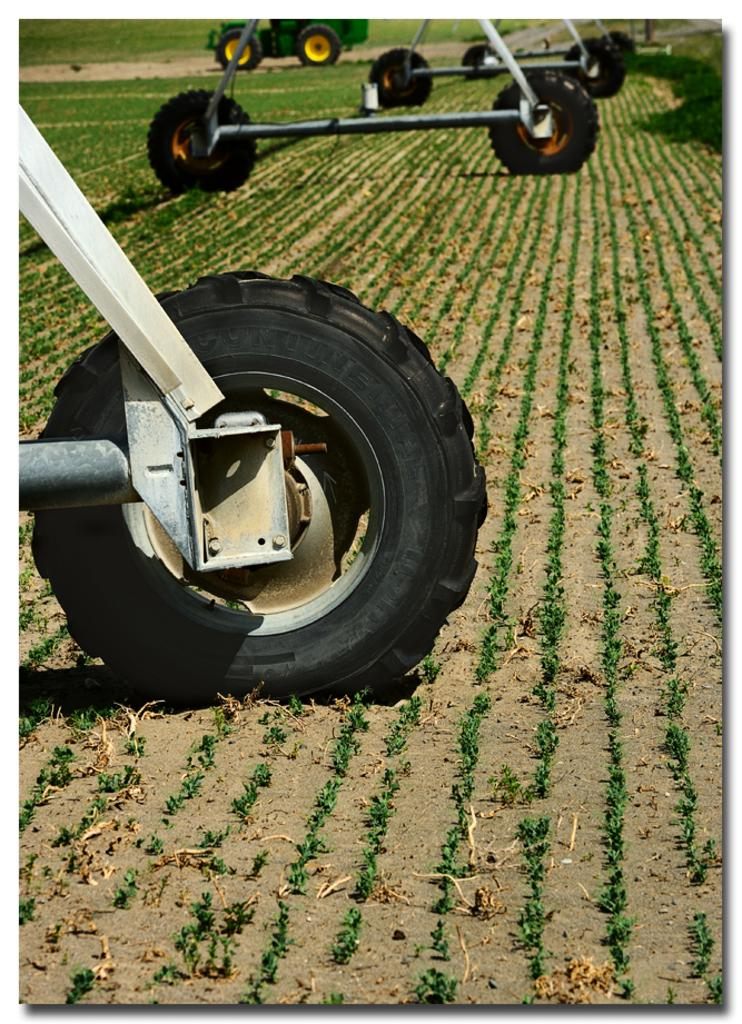What type of objects with wheels can be seen in the image? There are vehicles with wheels in the image. What type of landscape is visible in the image? There are fields visible in the image. Where is the vehicle located in the image? There is a vehicle on the road in the background of the image. What type of mask is being worn by the sleet in the image? There is no sleet or mask present in the image. Sleet is a type of precipitation and cannot wear a mask. 